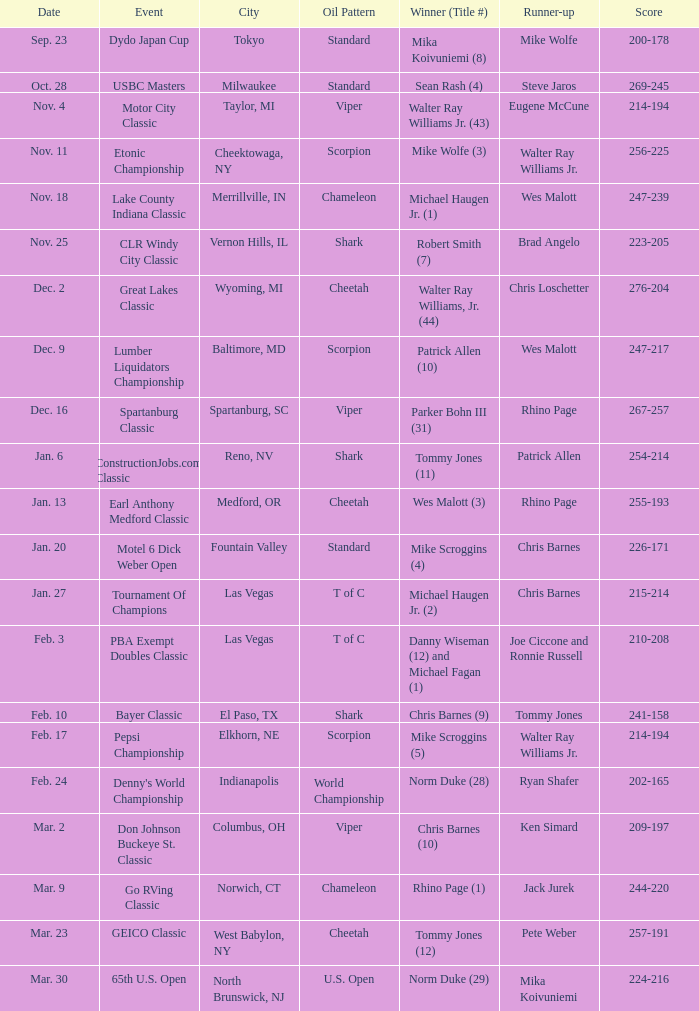Would you be able to parse every entry in this table? {'header': ['Date', 'Event', 'City', 'Oil Pattern', 'Winner (Title #)', 'Runner-up', 'Score'], 'rows': [['Sep. 23', 'Dydo Japan Cup', 'Tokyo', 'Standard', 'Mika Koivuniemi (8)', 'Mike Wolfe', '200-178'], ['Oct. 28', 'USBC Masters', 'Milwaukee', 'Standard', 'Sean Rash (4)', 'Steve Jaros', '269-245'], ['Nov. 4', 'Motor City Classic', 'Taylor, MI', 'Viper', 'Walter Ray Williams Jr. (43)', 'Eugene McCune', '214-194'], ['Nov. 11', 'Etonic Championship', 'Cheektowaga, NY', 'Scorpion', 'Mike Wolfe (3)', 'Walter Ray Williams Jr.', '256-225'], ['Nov. 18', 'Lake County Indiana Classic', 'Merrillville, IN', 'Chameleon', 'Michael Haugen Jr. (1)', 'Wes Malott', '247-239'], ['Nov. 25', 'CLR Windy City Classic', 'Vernon Hills, IL', 'Shark', 'Robert Smith (7)', 'Brad Angelo', '223-205'], ['Dec. 2', 'Great Lakes Classic', 'Wyoming, MI', 'Cheetah', 'Walter Ray Williams, Jr. (44)', 'Chris Loschetter', '276-204'], ['Dec. 9', 'Lumber Liquidators Championship', 'Baltimore, MD', 'Scorpion', 'Patrick Allen (10)', 'Wes Malott', '247-217'], ['Dec. 16', 'Spartanburg Classic', 'Spartanburg, SC', 'Viper', 'Parker Bohn III (31)', 'Rhino Page', '267-257'], ['Jan. 6', 'ConstructionJobs.com Classic', 'Reno, NV', 'Shark', 'Tommy Jones (11)', 'Patrick Allen', '254-214'], ['Jan. 13', 'Earl Anthony Medford Classic', 'Medford, OR', 'Cheetah', 'Wes Malott (3)', 'Rhino Page', '255-193'], ['Jan. 20', 'Motel 6 Dick Weber Open', 'Fountain Valley', 'Standard', 'Mike Scroggins (4)', 'Chris Barnes', '226-171'], ['Jan. 27', 'Tournament Of Champions', 'Las Vegas', 'T of C', 'Michael Haugen Jr. (2)', 'Chris Barnes', '215-214'], ['Feb. 3', 'PBA Exempt Doubles Classic', 'Las Vegas', 'T of C', 'Danny Wiseman (12) and Michael Fagan (1)', 'Joe Ciccone and Ronnie Russell', '210-208'], ['Feb. 10', 'Bayer Classic', 'El Paso, TX', 'Shark', 'Chris Barnes (9)', 'Tommy Jones', '241-158'], ['Feb. 17', 'Pepsi Championship', 'Elkhorn, NE', 'Scorpion', 'Mike Scroggins (5)', 'Walter Ray Williams Jr.', '214-194'], ['Feb. 24', "Denny's World Championship", 'Indianapolis', 'World Championship', 'Norm Duke (28)', 'Ryan Shafer', '202-165'], ['Mar. 2', 'Don Johnson Buckeye St. Classic', 'Columbus, OH', 'Viper', 'Chris Barnes (10)', 'Ken Simard', '209-197'], ['Mar. 9', 'Go RVing Classic', 'Norwich, CT', 'Chameleon', 'Rhino Page (1)', 'Jack Jurek', '244-220'], ['Mar. 23', 'GEICO Classic', 'West Babylon, NY', 'Cheetah', 'Tommy Jones (12)', 'Pete Weber', '257-191'], ['Mar. 30', '65th U.S. Open', 'North Brunswick, NJ', 'U.S. Open', 'Norm Duke (29)', 'Mika Koivuniemi', '224-216']]} Which Oil Pattern has a Winner (Title #) of mike wolfe (3)? Scorpion. 